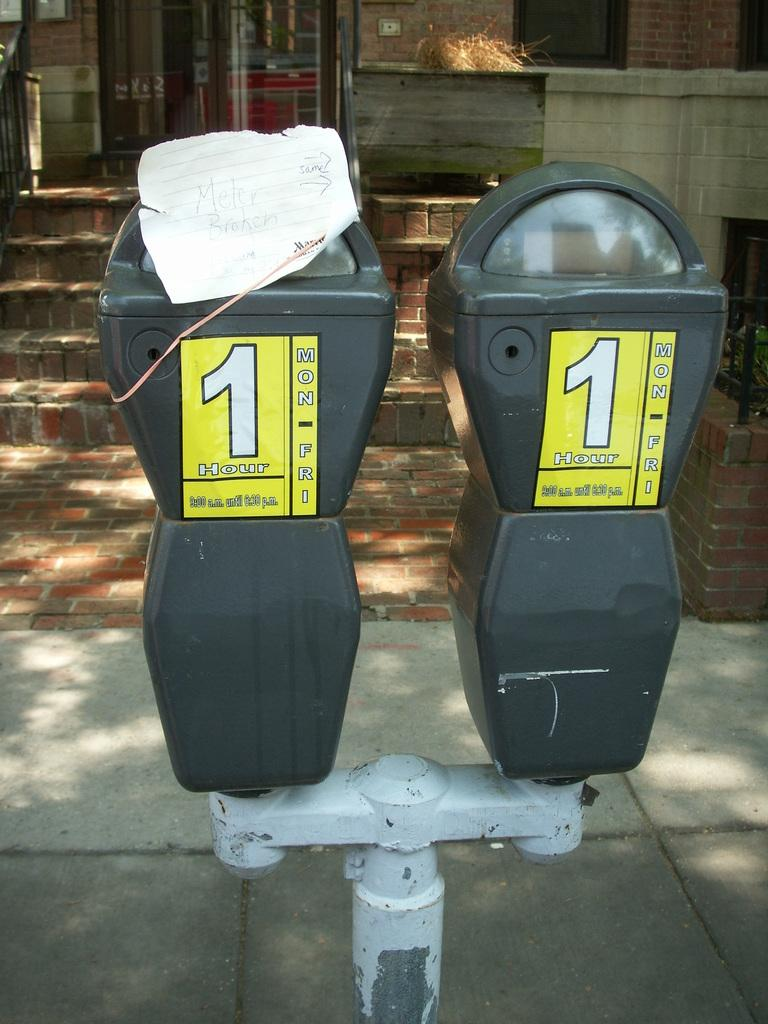<image>
Share a concise interpretation of the image provided. Two toll meters with yellow stickers that read 1 hour only. 